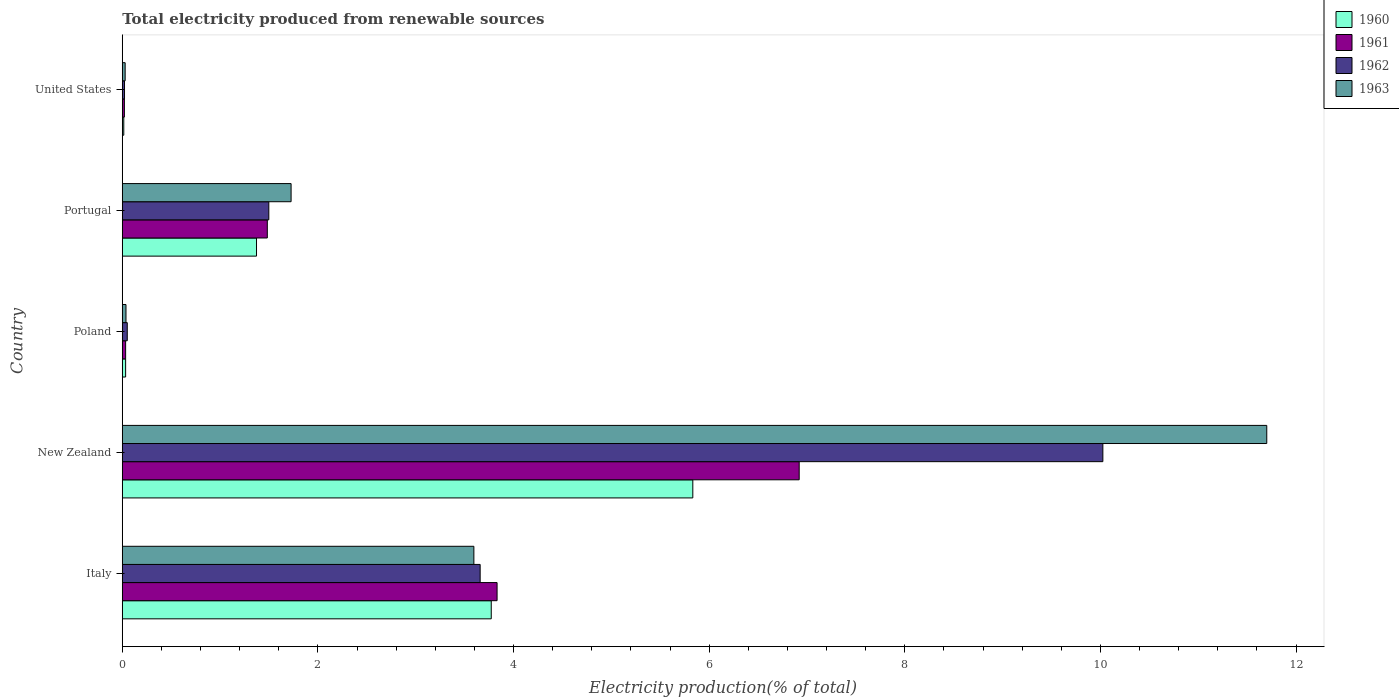How many groups of bars are there?
Give a very brief answer. 5. Are the number of bars on each tick of the Y-axis equal?
Your response must be concise. Yes. How many bars are there on the 2nd tick from the top?
Keep it short and to the point. 4. What is the label of the 3rd group of bars from the top?
Make the answer very short. Poland. In how many cases, is the number of bars for a given country not equal to the number of legend labels?
Your answer should be compact. 0. What is the total electricity produced in 1961 in New Zealand?
Offer a very short reply. 6.92. Across all countries, what is the maximum total electricity produced in 1960?
Your answer should be very brief. 5.83. Across all countries, what is the minimum total electricity produced in 1962?
Give a very brief answer. 0.02. In which country was the total electricity produced in 1961 maximum?
Keep it short and to the point. New Zealand. In which country was the total electricity produced in 1962 minimum?
Provide a succinct answer. United States. What is the total total electricity produced in 1960 in the graph?
Your response must be concise. 11.03. What is the difference between the total electricity produced in 1962 in New Zealand and that in Portugal?
Keep it short and to the point. 8.53. What is the difference between the total electricity produced in 1963 in Poland and the total electricity produced in 1962 in New Zealand?
Offer a very short reply. -9.99. What is the average total electricity produced in 1960 per country?
Your answer should be very brief. 2.21. What is the difference between the total electricity produced in 1963 and total electricity produced in 1960 in Poland?
Provide a short and direct response. 0. What is the ratio of the total electricity produced in 1963 in New Zealand to that in Portugal?
Keep it short and to the point. 6.78. What is the difference between the highest and the second highest total electricity produced in 1961?
Give a very brief answer. 3.09. What is the difference between the highest and the lowest total electricity produced in 1961?
Give a very brief answer. 6.9. In how many countries, is the total electricity produced in 1962 greater than the average total electricity produced in 1962 taken over all countries?
Ensure brevity in your answer.  2. Is the sum of the total electricity produced in 1963 in Italy and United States greater than the maximum total electricity produced in 1961 across all countries?
Provide a succinct answer. No. What does the 4th bar from the top in United States represents?
Your answer should be very brief. 1960. How many bars are there?
Offer a very short reply. 20. Are all the bars in the graph horizontal?
Your answer should be compact. Yes. What is the difference between two consecutive major ticks on the X-axis?
Provide a succinct answer. 2. Are the values on the major ticks of X-axis written in scientific E-notation?
Your answer should be compact. No. Does the graph contain any zero values?
Make the answer very short. No. How are the legend labels stacked?
Ensure brevity in your answer.  Vertical. What is the title of the graph?
Keep it short and to the point. Total electricity produced from renewable sources. Does "1962" appear as one of the legend labels in the graph?
Ensure brevity in your answer.  Yes. What is the label or title of the Y-axis?
Offer a very short reply. Country. What is the Electricity production(% of total) of 1960 in Italy?
Offer a very short reply. 3.77. What is the Electricity production(% of total) in 1961 in Italy?
Give a very brief answer. 3.83. What is the Electricity production(% of total) of 1962 in Italy?
Provide a succinct answer. 3.66. What is the Electricity production(% of total) in 1963 in Italy?
Your answer should be compact. 3.59. What is the Electricity production(% of total) in 1960 in New Zealand?
Provide a succinct answer. 5.83. What is the Electricity production(% of total) of 1961 in New Zealand?
Give a very brief answer. 6.92. What is the Electricity production(% of total) of 1962 in New Zealand?
Offer a terse response. 10.02. What is the Electricity production(% of total) in 1963 in New Zealand?
Offer a terse response. 11.7. What is the Electricity production(% of total) in 1960 in Poland?
Provide a succinct answer. 0.03. What is the Electricity production(% of total) in 1961 in Poland?
Give a very brief answer. 0.03. What is the Electricity production(% of total) of 1962 in Poland?
Offer a terse response. 0.05. What is the Electricity production(% of total) of 1963 in Poland?
Make the answer very short. 0.04. What is the Electricity production(% of total) of 1960 in Portugal?
Your answer should be compact. 1.37. What is the Electricity production(% of total) in 1961 in Portugal?
Offer a terse response. 1.48. What is the Electricity production(% of total) in 1962 in Portugal?
Offer a terse response. 1.5. What is the Electricity production(% of total) of 1963 in Portugal?
Provide a short and direct response. 1.73. What is the Electricity production(% of total) in 1960 in United States?
Offer a very short reply. 0.02. What is the Electricity production(% of total) of 1961 in United States?
Ensure brevity in your answer.  0.02. What is the Electricity production(% of total) in 1962 in United States?
Your response must be concise. 0.02. What is the Electricity production(% of total) of 1963 in United States?
Make the answer very short. 0.03. Across all countries, what is the maximum Electricity production(% of total) in 1960?
Provide a short and direct response. 5.83. Across all countries, what is the maximum Electricity production(% of total) in 1961?
Make the answer very short. 6.92. Across all countries, what is the maximum Electricity production(% of total) of 1962?
Offer a very short reply. 10.02. Across all countries, what is the maximum Electricity production(% of total) of 1963?
Your answer should be very brief. 11.7. Across all countries, what is the minimum Electricity production(% of total) of 1960?
Ensure brevity in your answer.  0.02. Across all countries, what is the minimum Electricity production(% of total) of 1961?
Your response must be concise. 0.02. Across all countries, what is the minimum Electricity production(% of total) of 1962?
Offer a very short reply. 0.02. Across all countries, what is the minimum Electricity production(% of total) in 1963?
Your answer should be compact. 0.03. What is the total Electricity production(% of total) of 1960 in the graph?
Your answer should be compact. 11.03. What is the total Electricity production(% of total) in 1961 in the graph?
Your response must be concise. 12.29. What is the total Electricity production(% of total) in 1962 in the graph?
Keep it short and to the point. 15.25. What is the total Electricity production(% of total) in 1963 in the graph?
Provide a succinct answer. 17.09. What is the difference between the Electricity production(% of total) in 1960 in Italy and that in New Zealand?
Ensure brevity in your answer.  -2.06. What is the difference between the Electricity production(% of total) of 1961 in Italy and that in New Zealand?
Provide a short and direct response. -3.09. What is the difference between the Electricity production(% of total) in 1962 in Italy and that in New Zealand?
Your response must be concise. -6.37. What is the difference between the Electricity production(% of total) in 1963 in Italy and that in New Zealand?
Your answer should be very brief. -8.11. What is the difference between the Electricity production(% of total) in 1960 in Italy and that in Poland?
Offer a terse response. 3.74. What is the difference between the Electricity production(% of total) in 1961 in Italy and that in Poland?
Give a very brief answer. 3.8. What is the difference between the Electricity production(% of total) in 1962 in Italy and that in Poland?
Your answer should be very brief. 3.61. What is the difference between the Electricity production(% of total) of 1963 in Italy and that in Poland?
Your answer should be very brief. 3.56. What is the difference between the Electricity production(% of total) of 1960 in Italy and that in Portugal?
Ensure brevity in your answer.  2.4. What is the difference between the Electricity production(% of total) in 1961 in Italy and that in Portugal?
Offer a terse response. 2.35. What is the difference between the Electricity production(% of total) of 1962 in Italy and that in Portugal?
Keep it short and to the point. 2.16. What is the difference between the Electricity production(% of total) of 1963 in Italy and that in Portugal?
Your response must be concise. 1.87. What is the difference between the Electricity production(% of total) in 1960 in Italy and that in United States?
Offer a very short reply. 3.76. What is the difference between the Electricity production(% of total) in 1961 in Italy and that in United States?
Provide a short and direct response. 3.81. What is the difference between the Electricity production(% of total) of 1962 in Italy and that in United States?
Keep it short and to the point. 3.64. What is the difference between the Electricity production(% of total) of 1963 in Italy and that in United States?
Make the answer very short. 3.56. What is the difference between the Electricity production(% of total) of 1960 in New Zealand and that in Poland?
Your response must be concise. 5.8. What is the difference between the Electricity production(% of total) in 1961 in New Zealand and that in Poland?
Offer a terse response. 6.89. What is the difference between the Electricity production(% of total) in 1962 in New Zealand and that in Poland?
Offer a very short reply. 9.97. What is the difference between the Electricity production(% of total) in 1963 in New Zealand and that in Poland?
Provide a succinct answer. 11.66. What is the difference between the Electricity production(% of total) in 1960 in New Zealand and that in Portugal?
Make the answer very short. 4.46. What is the difference between the Electricity production(% of total) in 1961 in New Zealand and that in Portugal?
Ensure brevity in your answer.  5.44. What is the difference between the Electricity production(% of total) in 1962 in New Zealand and that in Portugal?
Ensure brevity in your answer.  8.53. What is the difference between the Electricity production(% of total) of 1963 in New Zealand and that in Portugal?
Give a very brief answer. 9.97. What is the difference between the Electricity production(% of total) in 1960 in New Zealand and that in United States?
Keep it short and to the point. 5.82. What is the difference between the Electricity production(% of total) of 1961 in New Zealand and that in United States?
Your answer should be compact. 6.9. What is the difference between the Electricity production(% of total) of 1962 in New Zealand and that in United States?
Ensure brevity in your answer.  10. What is the difference between the Electricity production(% of total) of 1963 in New Zealand and that in United States?
Your answer should be very brief. 11.67. What is the difference between the Electricity production(% of total) of 1960 in Poland and that in Portugal?
Offer a very short reply. -1.34. What is the difference between the Electricity production(% of total) in 1961 in Poland and that in Portugal?
Provide a succinct answer. -1.45. What is the difference between the Electricity production(% of total) of 1962 in Poland and that in Portugal?
Offer a terse response. -1.45. What is the difference between the Electricity production(% of total) of 1963 in Poland and that in Portugal?
Your answer should be very brief. -1.69. What is the difference between the Electricity production(% of total) of 1960 in Poland and that in United States?
Give a very brief answer. 0.02. What is the difference between the Electricity production(% of total) in 1961 in Poland and that in United States?
Your answer should be very brief. 0.01. What is the difference between the Electricity production(% of total) of 1962 in Poland and that in United States?
Your answer should be very brief. 0.03. What is the difference between the Electricity production(% of total) of 1963 in Poland and that in United States?
Give a very brief answer. 0.01. What is the difference between the Electricity production(% of total) of 1960 in Portugal and that in United States?
Offer a terse response. 1.36. What is the difference between the Electricity production(% of total) in 1961 in Portugal and that in United States?
Provide a short and direct response. 1.46. What is the difference between the Electricity production(% of total) in 1962 in Portugal and that in United States?
Offer a very short reply. 1.48. What is the difference between the Electricity production(% of total) in 1963 in Portugal and that in United States?
Provide a short and direct response. 1.7. What is the difference between the Electricity production(% of total) in 1960 in Italy and the Electricity production(% of total) in 1961 in New Zealand?
Your response must be concise. -3.15. What is the difference between the Electricity production(% of total) in 1960 in Italy and the Electricity production(% of total) in 1962 in New Zealand?
Provide a succinct answer. -6.25. What is the difference between the Electricity production(% of total) in 1960 in Italy and the Electricity production(% of total) in 1963 in New Zealand?
Provide a short and direct response. -7.93. What is the difference between the Electricity production(% of total) of 1961 in Italy and the Electricity production(% of total) of 1962 in New Zealand?
Your answer should be very brief. -6.19. What is the difference between the Electricity production(% of total) of 1961 in Italy and the Electricity production(% of total) of 1963 in New Zealand?
Offer a very short reply. -7.87. What is the difference between the Electricity production(% of total) of 1962 in Italy and the Electricity production(% of total) of 1963 in New Zealand?
Offer a very short reply. -8.04. What is the difference between the Electricity production(% of total) in 1960 in Italy and the Electricity production(% of total) in 1961 in Poland?
Keep it short and to the point. 3.74. What is the difference between the Electricity production(% of total) in 1960 in Italy and the Electricity production(% of total) in 1962 in Poland?
Keep it short and to the point. 3.72. What is the difference between the Electricity production(% of total) of 1960 in Italy and the Electricity production(% of total) of 1963 in Poland?
Make the answer very short. 3.73. What is the difference between the Electricity production(% of total) in 1961 in Italy and the Electricity production(% of total) in 1962 in Poland?
Give a very brief answer. 3.78. What is the difference between the Electricity production(% of total) of 1961 in Italy and the Electricity production(% of total) of 1963 in Poland?
Make the answer very short. 3.79. What is the difference between the Electricity production(% of total) of 1962 in Italy and the Electricity production(% of total) of 1963 in Poland?
Offer a terse response. 3.62. What is the difference between the Electricity production(% of total) of 1960 in Italy and the Electricity production(% of total) of 1961 in Portugal?
Give a very brief answer. 2.29. What is the difference between the Electricity production(% of total) of 1960 in Italy and the Electricity production(% of total) of 1962 in Portugal?
Offer a very short reply. 2.27. What is the difference between the Electricity production(% of total) of 1960 in Italy and the Electricity production(% of total) of 1963 in Portugal?
Make the answer very short. 2.05. What is the difference between the Electricity production(% of total) of 1961 in Italy and the Electricity production(% of total) of 1962 in Portugal?
Ensure brevity in your answer.  2.33. What is the difference between the Electricity production(% of total) of 1961 in Italy and the Electricity production(% of total) of 1963 in Portugal?
Make the answer very short. 2.11. What is the difference between the Electricity production(% of total) in 1962 in Italy and the Electricity production(% of total) in 1963 in Portugal?
Provide a short and direct response. 1.93. What is the difference between the Electricity production(% of total) in 1960 in Italy and the Electricity production(% of total) in 1961 in United States?
Provide a succinct answer. 3.75. What is the difference between the Electricity production(% of total) in 1960 in Italy and the Electricity production(% of total) in 1962 in United States?
Give a very brief answer. 3.75. What is the difference between the Electricity production(% of total) in 1960 in Italy and the Electricity production(% of total) in 1963 in United States?
Your answer should be compact. 3.74. What is the difference between the Electricity production(% of total) in 1961 in Italy and the Electricity production(% of total) in 1962 in United States?
Give a very brief answer. 3.81. What is the difference between the Electricity production(% of total) in 1961 in Italy and the Electricity production(% of total) in 1963 in United States?
Offer a very short reply. 3.8. What is the difference between the Electricity production(% of total) in 1962 in Italy and the Electricity production(% of total) in 1963 in United States?
Make the answer very short. 3.63. What is the difference between the Electricity production(% of total) of 1960 in New Zealand and the Electricity production(% of total) of 1961 in Poland?
Provide a succinct answer. 5.8. What is the difference between the Electricity production(% of total) of 1960 in New Zealand and the Electricity production(% of total) of 1962 in Poland?
Your answer should be compact. 5.78. What is the difference between the Electricity production(% of total) of 1960 in New Zealand and the Electricity production(% of total) of 1963 in Poland?
Provide a succinct answer. 5.79. What is the difference between the Electricity production(% of total) of 1961 in New Zealand and the Electricity production(% of total) of 1962 in Poland?
Keep it short and to the point. 6.87. What is the difference between the Electricity production(% of total) of 1961 in New Zealand and the Electricity production(% of total) of 1963 in Poland?
Ensure brevity in your answer.  6.88. What is the difference between the Electricity production(% of total) of 1962 in New Zealand and the Electricity production(% of total) of 1963 in Poland?
Offer a very short reply. 9.99. What is the difference between the Electricity production(% of total) of 1960 in New Zealand and the Electricity production(% of total) of 1961 in Portugal?
Make the answer very short. 4.35. What is the difference between the Electricity production(% of total) of 1960 in New Zealand and the Electricity production(% of total) of 1962 in Portugal?
Provide a succinct answer. 4.33. What is the difference between the Electricity production(% of total) of 1960 in New Zealand and the Electricity production(% of total) of 1963 in Portugal?
Give a very brief answer. 4.11. What is the difference between the Electricity production(% of total) of 1961 in New Zealand and the Electricity production(% of total) of 1962 in Portugal?
Your response must be concise. 5.42. What is the difference between the Electricity production(% of total) in 1961 in New Zealand and the Electricity production(% of total) in 1963 in Portugal?
Your response must be concise. 5.19. What is the difference between the Electricity production(% of total) of 1962 in New Zealand and the Electricity production(% of total) of 1963 in Portugal?
Offer a terse response. 8.3. What is the difference between the Electricity production(% of total) of 1960 in New Zealand and the Electricity production(% of total) of 1961 in United States?
Offer a very short reply. 5.81. What is the difference between the Electricity production(% of total) of 1960 in New Zealand and the Electricity production(% of total) of 1962 in United States?
Offer a very short reply. 5.81. What is the difference between the Electricity production(% of total) in 1960 in New Zealand and the Electricity production(% of total) in 1963 in United States?
Provide a succinct answer. 5.8. What is the difference between the Electricity production(% of total) in 1961 in New Zealand and the Electricity production(% of total) in 1962 in United States?
Offer a terse response. 6.9. What is the difference between the Electricity production(% of total) in 1961 in New Zealand and the Electricity production(% of total) in 1963 in United States?
Your answer should be compact. 6.89. What is the difference between the Electricity production(% of total) of 1962 in New Zealand and the Electricity production(% of total) of 1963 in United States?
Offer a terse response. 10. What is the difference between the Electricity production(% of total) of 1960 in Poland and the Electricity production(% of total) of 1961 in Portugal?
Provide a succinct answer. -1.45. What is the difference between the Electricity production(% of total) in 1960 in Poland and the Electricity production(% of total) in 1962 in Portugal?
Give a very brief answer. -1.46. What is the difference between the Electricity production(% of total) of 1960 in Poland and the Electricity production(% of total) of 1963 in Portugal?
Ensure brevity in your answer.  -1.69. What is the difference between the Electricity production(% of total) in 1961 in Poland and the Electricity production(% of total) in 1962 in Portugal?
Provide a short and direct response. -1.46. What is the difference between the Electricity production(% of total) of 1961 in Poland and the Electricity production(% of total) of 1963 in Portugal?
Keep it short and to the point. -1.69. What is the difference between the Electricity production(% of total) in 1962 in Poland and the Electricity production(% of total) in 1963 in Portugal?
Make the answer very short. -1.67. What is the difference between the Electricity production(% of total) in 1960 in Poland and the Electricity production(% of total) in 1961 in United States?
Provide a short and direct response. 0.01. What is the difference between the Electricity production(% of total) in 1960 in Poland and the Electricity production(% of total) in 1962 in United States?
Ensure brevity in your answer.  0.01. What is the difference between the Electricity production(% of total) of 1960 in Poland and the Electricity production(% of total) of 1963 in United States?
Give a very brief answer. 0. What is the difference between the Electricity production(% of total) of 1961 in Poland and the Electricity production(% of total) of 1962 in United States?
Provide a short and direct response. 0.01. What is the difference between the Electricity production(% of total) of 1961 in Poland and the Electricity production(% of total) of 1963 in United States?
Provide a succinct answer. 0. What is the difference between the Electricity production(% of total) of 1962 in Poland and the Electricity production(% of total) of 1963 in United States?
Provide a short and direct response. 0.02. What is the difference between the Electricity production(% of total) of 1960 in Portugal and the Electricity production(% of total) of 1961 in United States?
Provide a succinct answer. 1.35. What is the difference between the Electricity production(% of total) of 1960 in Portugal and the Electricity production(% of total) of 1962 in United States?
Your response must be concise. 1.35. What is the difference between the Electricity production(% of total) in 1960 in Portugal and the Electricity production(% of total) in 1963 in United States?
Offer a very short reply. 1.34. What is the difference between the Electricity production(% of total) of 1961 in Portugal and the Electricity production(% of total) of 1962 in United States?
Keep it short and to the point. 1.46. What is the difference between the Electricity production(% of total) in 1961 in Portugal and the Electricity production(% of total) in 1963 in United States?
Your answer should be very brief. 1.45. What is the difference between the Electricity production(% of total) in 1962 in Portugal and the Electricity production(% of total) in 1963 in United States?
Your answer should be very brief. 1.47. What is the average Electricity production(% of total) of 1960 per country?
Your response must be concise. 2.21. What is the average Electricity production(% of total) in 1961 per country?
Your answer should be very brief. 2.46. What is the average Electricity production(% of total) in 1962 per country?
Provide a short and direct response. 3.05. What is the average Electricity production(% of total) in 1963 per country?
Ensure brevity in your answer.  3.42. What is the difference between the Electricity production(% of total) of 1960 and Electricity production(% of total) of 1961 in Italy?
Offer a very short reply. -0.06. What is the difference between the Electricity production(% of total) of 1960 and Electricity production(% of total) of 1962 in Italy?
Provide a succinct answer. 0.11. What is the difference between the Electricity production(% of total) of 1960 and Electricity production(% of total) of 1963 in Italy?
Your answer should be very brief. 0.18. What is the difference between the Electricity production(% of total) in 1961 and Electricity production(% of total) in 1962 in Italy?
Provide a short and direct response. 0.17. What is the difference between the Electricity production(% of total) in 1961 and Electricity production(% of total) in 1963 in Italy?
Your answer should be very brief. 0.24. What is the difference between the Electricity production(% of total) in 1962 and Electricity production(% of total) in 1963 in Italy?
Your response must be concise. 0.06. What is the difference between the Electricity production(% of total) in 1960 and Electricity production(% of total) in 1961 in New Zealand?
Provide a short and direct response. -1.09. What is the difference between the Electricity production(% of total) in 1960 and Electricity production(% of total) in 1962 in New Zealand?
Your answer should be compact. -4.19. What is the difference between the Electricity production(% of total) of 1960 and Electricity production(% of total) of 1963 in New Zealand?
Your answer should be very brief. -5.87. What is the difference between the Electricity production(% of total) in 1961 and Electricity production(% of total) in 1962 in New Zealand?
Your response must be concise. -3.1. What is the difference between the Electricity production(% of total) in 1961 and Electricity production(% of total) in 1963 in New Zealand?
Give a very brief answer. -4.78. What is the difference between the Electricity production(% of total) in 1962 and Electricity production(% of total) in 1963 in New Zealand?
Keep it short and to the point. -1.68. What is the difference between the Electricity production(% of total) of 1960 and Electricity production(% of total) of 1962 in Poland?
Provide a short and direct response. -0.02. What is the difference between the Electricity production(% of total) in 1960 and Electricity production(% of total) in 1963 in Poland?
Provide a short and direct response. -0. What is the difference between the Electricity production(% of total) in 1961 and Electricity production(% of total) in 1962 in Poland?
Keep it short and to the point. -0.02. What is the difference between the Electricity production(% of total) of 1961 and Electricity production(% of total) of 1963 in Poland?
Offer a terse response. -0. What is the difference between the Electricity production(% of total) of 1962 and Electricity production(% of total) of 1963 in Poland?
Make the answer very short. 0.01. What is the difference between the Electricity production(% of total) of 1960 and Electricity production(% of total) of 1961 in Portugal?
Give a very brief answer. -0.11. What is the difference between the Electricity production(% of total) of 1960 and Electricity production(% of total) of 1962 in Portugal?
Give a very brief answer. -0.13. What is the difference between the Electricity production(% of total) of 1960 and Electricity production(% of total) of 1963 in Portugal?
Your answer should be very brief. -0.35. What is the difference between the Electricity production(% of total) of 1961 and Electricity production(% of total) of 1962 in Portugal?
Offer a very short reply. -0.02. What is the difference between the Electricity production(% of total) in 1961 and Electricity production(% of total) in 1963 in Portugal?
Your response must be concise. -0.24. What is the difference between the Electricity production(% of total) of 1962 and Electricity production(% of total) of 1963 in Portugal?
Your answer should be very brief. -0.23. What is the difference between the Electricity production(% of total) of 1960 and Electricity production(% of total) of 1961 in United States?
Make the answer very short. -0.01. What is the difference between the Electricity production(% of total) in 1960 and Electricity production(% of total) in 1962 in United States?
Your answer should be very brief. -0.01. What is the difference between the Electricity production(% of total) of 1960 and Electricity production(% of total) of 1963 in United States?
Give a very brief answer. -0.01. What is the difference between the Electricity production(% of total) in 1961 and Electricity production(% of total) in 1962 in United States?
Keep it short and to the point. -0. What is the difference between the Electricity production(% of total) in 1961 and Electricity production(% of total) in 1963 in United States?
Provide a short and direct response. -0.01. What is the difference between the Electricity production(% of total) in 1962 and Electricity production(% of total) in 1963 in United States?
Keep it short and to the point. -0.01. What is the ratio of the Electricity production(% of total) of 1960 in Italy to that in New Zealand?
Your response must be concise. 0.65. What is the ratio of the Electricity production(% of total) of 1961 in Italy to that in New Zealand?
Offer a very short reply. 0.55. What is the ratio of the Electricity production(% of total) in 1962 in Italy to that in New Zealand?
Offer a very short reply. 0.36. What is the ratio of the Electricity production(% of total) in 1963 in Italy to that in New Zealand?
Make the answer very short. 0.31. What is the ratio of the Electricity production(% of total) in 1960 in Italy to that in Poland?
Offer a very short reply. 110.45. What is the ratio of the Electricity production(% of total) in 1961 in Italy to that in Poland?
Provide a succinct answer. 112.3. What is the ratio of the Electricity production(% of total) of 1962 in Italy to that in Poland?
Offer a very short reply. 71.88. What is the ratio of the Electricity production(% of total) in 1963 in Italy to that in Poland?
Your answer should be compact. 94.84. What is the ratio of the Electricity production(% of total) in 1960 in Italy to that in Portugal?
Your answer should be very brief. 2.75. What is the ratio of the Electricity production(% of total) of 1961 in Italy to that in Portugal?
Make the answer very short. 2.58. What is the ratio of the Electricity production(% of total) of 1962 in Italy to that in Portugal?
Provide a succinct answer. 2.44. What is the ratio of the Electricity production(% of total) in 1963 in Italy to that in Portugal?
Your answer should be very brief. 2.08. What is the ratio of the Electricity production(% of total) in 1960 in Italy to that in United States?
Provide a succinct answer. 247.25. What is the ratio of the Electricity production(% of total) in 1961 in Italy to that in United States?
Offer a terse response. 177.87. What is the ratio of the Electricity production(% of total) of 1962 in Italy to that in United States?
Keep it short and to the point. 160.56. What is the ratio of the Electricity production(% of total) of 1963 in Italy to that in United States?
Provide a succinct answer. 122.12. What is the ratio of the Electricity production(% of total) of 1960 in New Zealand to that in Poland?
Your response must be concise. 170.79. What is the ratio of the Electricity production(% of total) of 1961 in New Zealand to that in Poland?
Give a very brief answer. 202.83. What is the ratio of the Electricity production(% of total) in 1962 in New Zealand to that in Poland?
Make the answer very short. 196.95. What is the ratio of the Electricity production(% of total) of 1963 in New Zealand to that in Poland?
Keep it short and to the point. 308.73. What is the ratio of the Electricity production(% of total) of 1960 in New Zealand to that in Portugal?
Provide a succinct answer. 4.25. What is the ratio of the Electricity production(% of total) of 1961 in New Zealand to that in Portugal?
Offer a terse response. 4.67. What is the ratio of the Electricity production(% of total) of 1962 in New Zealand to that in Portugal?
Give a very brief answer. 6.69. What is the ratio of the Electricity production(% of total) in 1963 in New Zealand to that in Portugal?
Give a very brief answer. 6.78. What is the ratio of the Electricity production(% of total) of 1960 in New Zealand to that in United States?
Make the answer very short. 382.31. What is the ratio of the Electricity production(% of total) of 1961 in New Zealand to that in United States?
Your answer should be compact. 321.25. What is the ratio of the Electricity production(% of total) of 1962 in New Zealand to that in United States?
Your answer should be compact. 439.93. What is the ratio of the Electricity production(% of total) of 1963 in New Zealand to that in United States?
Your answer should be very brief. 397.5. What is the ratio of the Electricity production(% of total) of 1960 in Poland to that in Portugal?
Your response must be concise. 0.02. What is the ratio of the Electricity production(% of total) of 1961 in Poland to that in Portugal?
Your answer should be compact. 0.02. What is the ratio of the Electricity production(% of total) in 1962 in Poland to that in Portugal?
Ensure brevity in your answer.  0.03. What is the ratio of the Electricity production(% of total) of 1963 in Poland to that in Portugal?
Provide a succinct answer. 0.02. What is the ratio of the Electricity production(% of total) in 1960 in Poland to that in United States?
Keep it short and to the point. 2.24. What is the ratio of the Electricity production(% of total) of 1961 in Poland to that in United States?
Offer a very short reply. 1.58. What is the ratio of the Electricity production(% of total) of 1962 in Poland to that in United States?
Offer a very short reply. 2.23. What is the ratio of the Electricity production(% of total) of 1963 in Poland to that in United States?
Ensure brevity in your answer.  1.29. What is the ratio of the Electricity production(% of total) of 1960 in Portugal to that in United States?
Keep it short and to the point. 89.96. What is the ratio of the Electricity production(% of total) of 1961 in Portugal to that in United States?
Keep it short and to the point. 68.83. What is the ratio of the Electricity production(% of total) of 1962 in Portugal to that in United States?
Ensure brevity in your answer.  65.74. What is the ratio of the Electricity production(% of total) in 1963 in Portugal to that in United States?
Offer a very short reply. 58.63. What is the difference between the highest and the second highest Electricity production(% of total) in 1960?
Offer a terse response. 2.06. What is the difference between the highest and the second highest Electricity production(% of total) of 1961?
Keep it short and to the point. 3.09. What is the difference between the highest and the second highest Electricity production(% of total) in 1962?
Your answer should be very brief. 6.37. What is the difference between the highest and the second highest Electricity production(% of total) in 1963?
Ensure brevity in your answer.  8.11. What is the difference between the highest and the lowest Electricity production(% of total) in 1960?
Give a very brief answer. 5.82. What is the difference between the highest and the lowest Electricity production(% of total) in 1961?
Offer a very short reply. 6.9. What is the difference between the highest and the lowest Electricity production(% of total) in 1962?
Offer a terse response. 10. What is the difference between the highest and the lowest Electricity production(% of total) of 1963?
Offer a terse response. 11.67. 